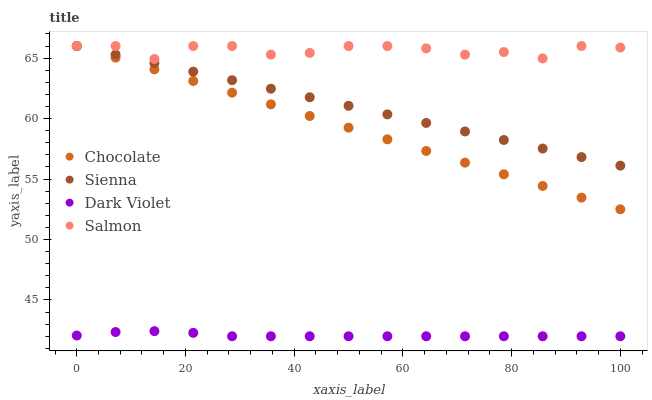Does Dark Violet have the minimum area under the curve?
Answer yes or no. Yes. Does Salmon have the maximum area under the curve?
Answer yes or no. Yes. Does Salmon have the minimum area under the curve?
Answer yes or no. No. Does Dark Violet have the maximum area under the curve?
Answer yes or no. No. Is Chocolate the smoothest?
Answer yes or no. Yes. Is Salmon the roughest?
Answer yes or no. Yes. Is Dark Violet the smoothest?
Answer yes or no. No. Is Dark Violet the roughest?
Answer yes or no. No. Does Dark Violet have the lowest value?
Answer yes or no. Yes. Does Salmon have the lowest value?
Answer yes or no. No. Does Chocolate have the highest value?
Answer yes or no. Yes. Does Dark Violet have the highest value?
Answer yes or no. No. Is Dark Violet less than Sienna?
Answer yes or no. Yes. Is Sienna greater than Dark Violet?
Answer yes or no. Yes. Does Chocolate intersect Salmon?
Answer yes or no. Yes. Is Chocolate less than Salmon?
Answer yes or no. No. Is Chocolate greater than Salmon?
Answer yes or no. No. Does Dark Violet intersect Sienna?
Answer yes or no. No. 